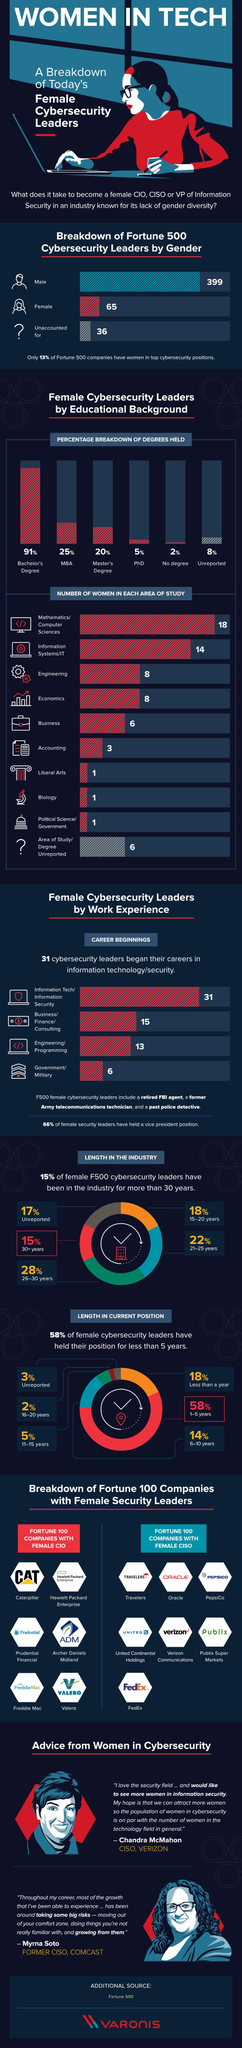Mention a couple of crucial points in this snapshot. Six female executives from Fortune 500 companies who specialize in cybersecurity began their careers in government or military positions. According to a recent study, there are only 65 female F500 cybersecurity leaders, representing a significant underrepresentation of women in this field. The majority of female F500 cybersecurity leaders hold a Bachelor's degree. According to the survey, 22% of female F500 cybersecurity leaders have been in the industry for 21-25 years. Of the female F500 cybersecurity leaders, only 5% hold a PhD. 